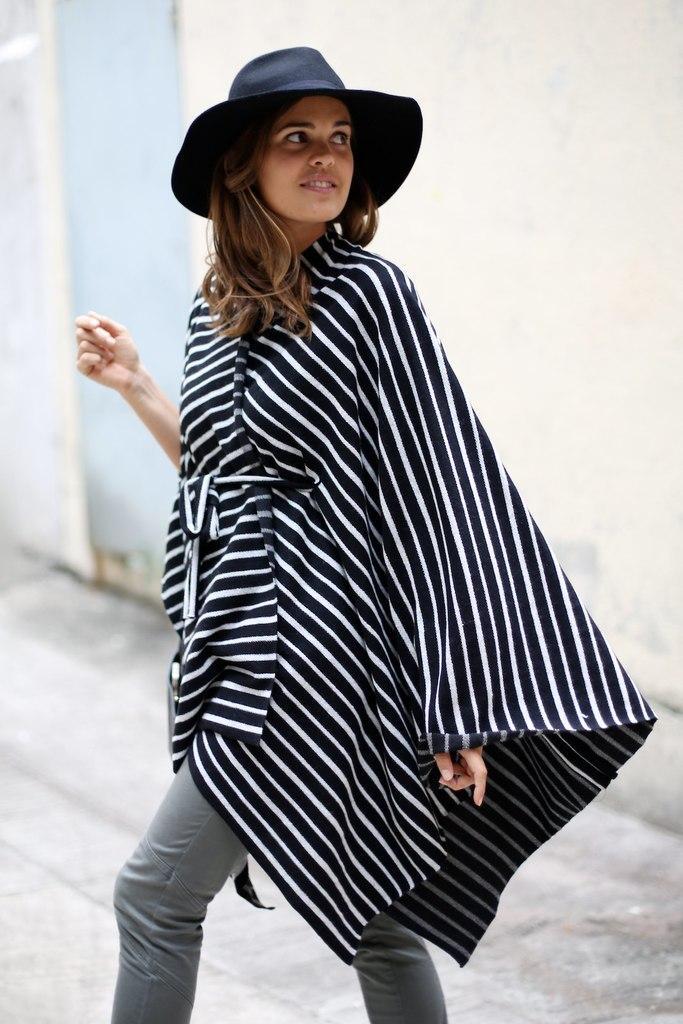Could you give a brief overview of what you see in this image? In the image there is a woman in the front in black and white striped dress and black hat walking in the street, in the back there is a wall. 